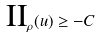Convert formula to latex. <formula><loc_0><loc_0><loc_500><loc_500>\text {II} _ { \rho } ( u ) \geq - C</formula> 